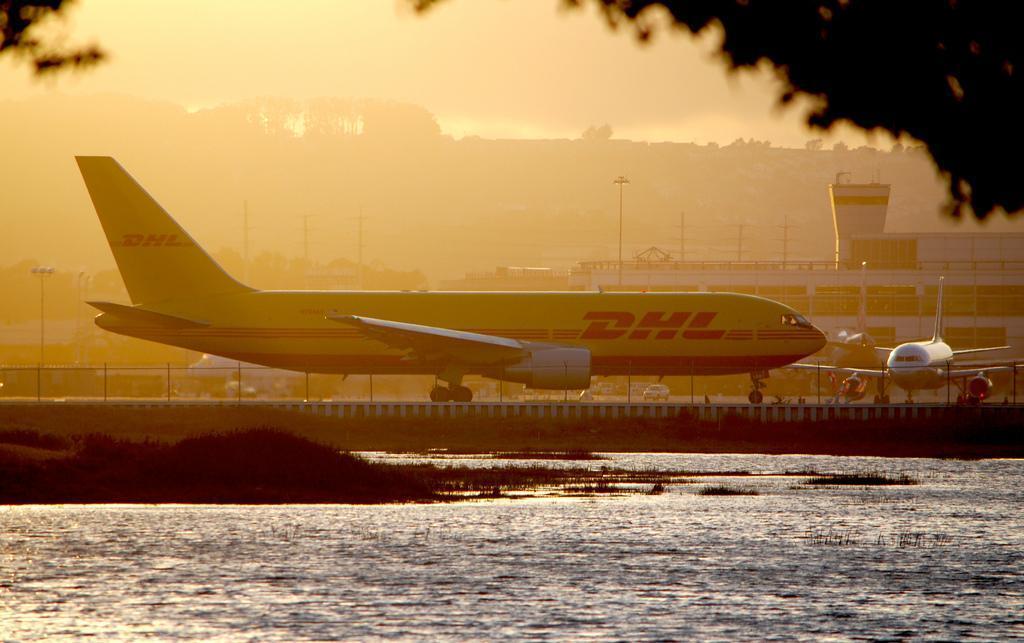How many airplanes can be seen?
Give a very brief answer. 2. 